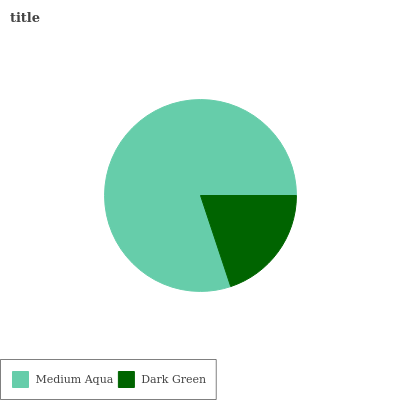Is Dark Green the minimum?
Answer yes or no. Yes. Is Medium Aqua the maximum?
Answer yes or no. Yes. Is Dark Green the maximum?
Answer yes or no. No. Is Medium Aqua greater than Dark Green?
Answer yes or no. Yes. Is Dark Green less than Medium Aqua?
Answer yes or no. Yes. Is Dark Green greater than Medium Aqua?
Answer yes or no. No. Is Medium Aqua less than Dark Green?
Answer yes or no. No. Is Medium Aqua the high median?
Answer yes or no. Yes. Is Dark Green the low median?
Answer yes or no. Yes. Is Dark Green the high median?
Answer yes or no. No. Is Medium Aqua the low median?
Answer yes or no. No. 